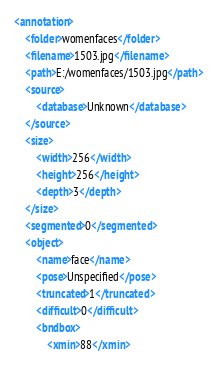Convert code to text. <code><loc_0><loc_0><loc_500><loc_500><_XML_><annotation>
	<folder>womenfaces</folder>
	<filename>1503.jpg</filename>
	<path>E:/womenfaces/1503.jpg</path>
	<source>
		<database>Unknown</database>
	</source>
	<size>
		<width>256</width>
		<height>256</height>
		<depth>3</depth>
	</size>
	<segmented>0</segmented>
	<object>
		<name>face</name>
		<pose>Unspecified</pose>
		<truncated>1</truncated>
		<difficult>0</difficult>
		<bndbox>
			<xmin>88</xmin></code> 